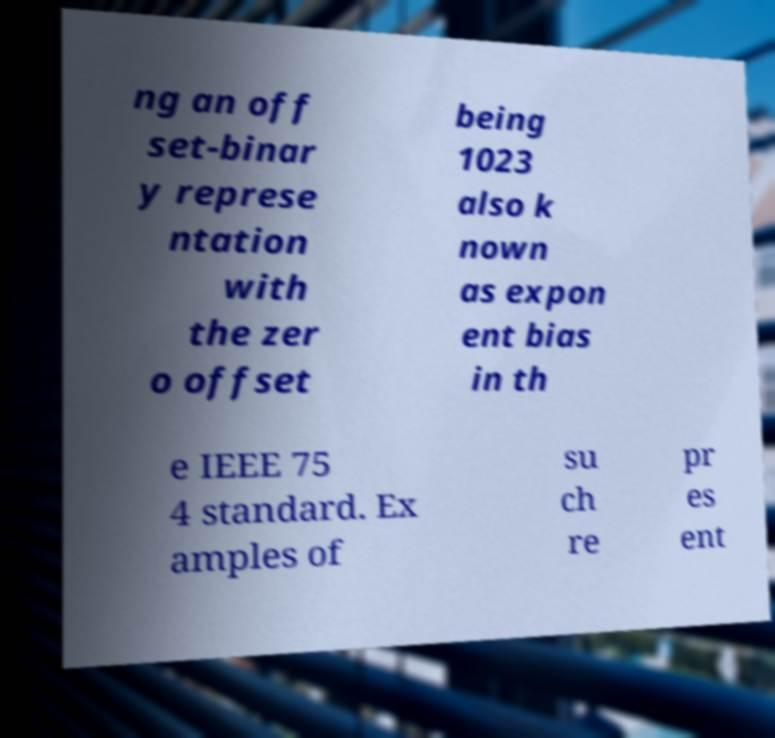Please read and relay the text visible in this image. What does it say? ng an off set-binar y represe ntation with the zer o offset being 1023 also k nown as expon ent bias in th e IEEE 75 4 standard. Ex amples of su ch re pr es ent 